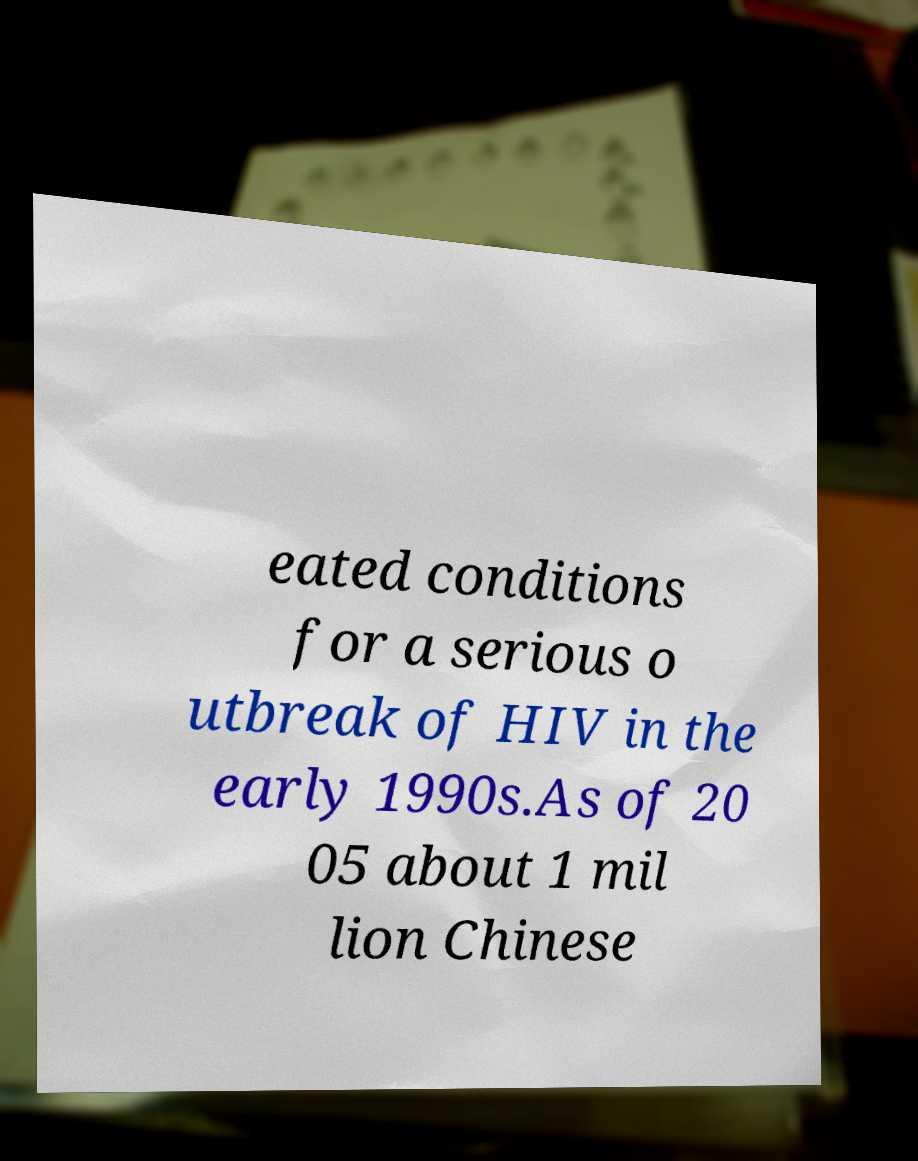Please identify and transcribe the text found in this image. eated conditions for a serious o utbreak of HIV in the early 1990s.As of 20 05 about 1 mil lion Chinese 